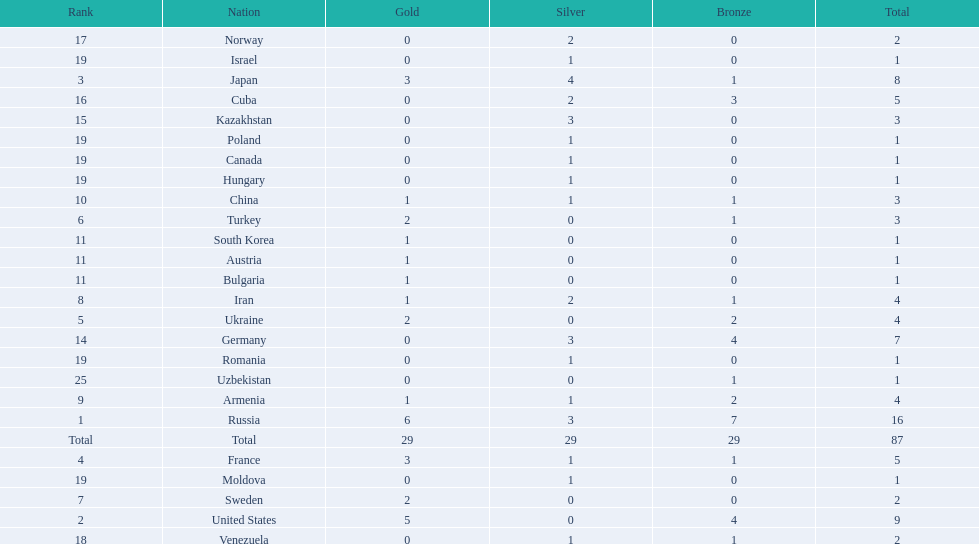Japan and france each won how many gold medals? 3. 